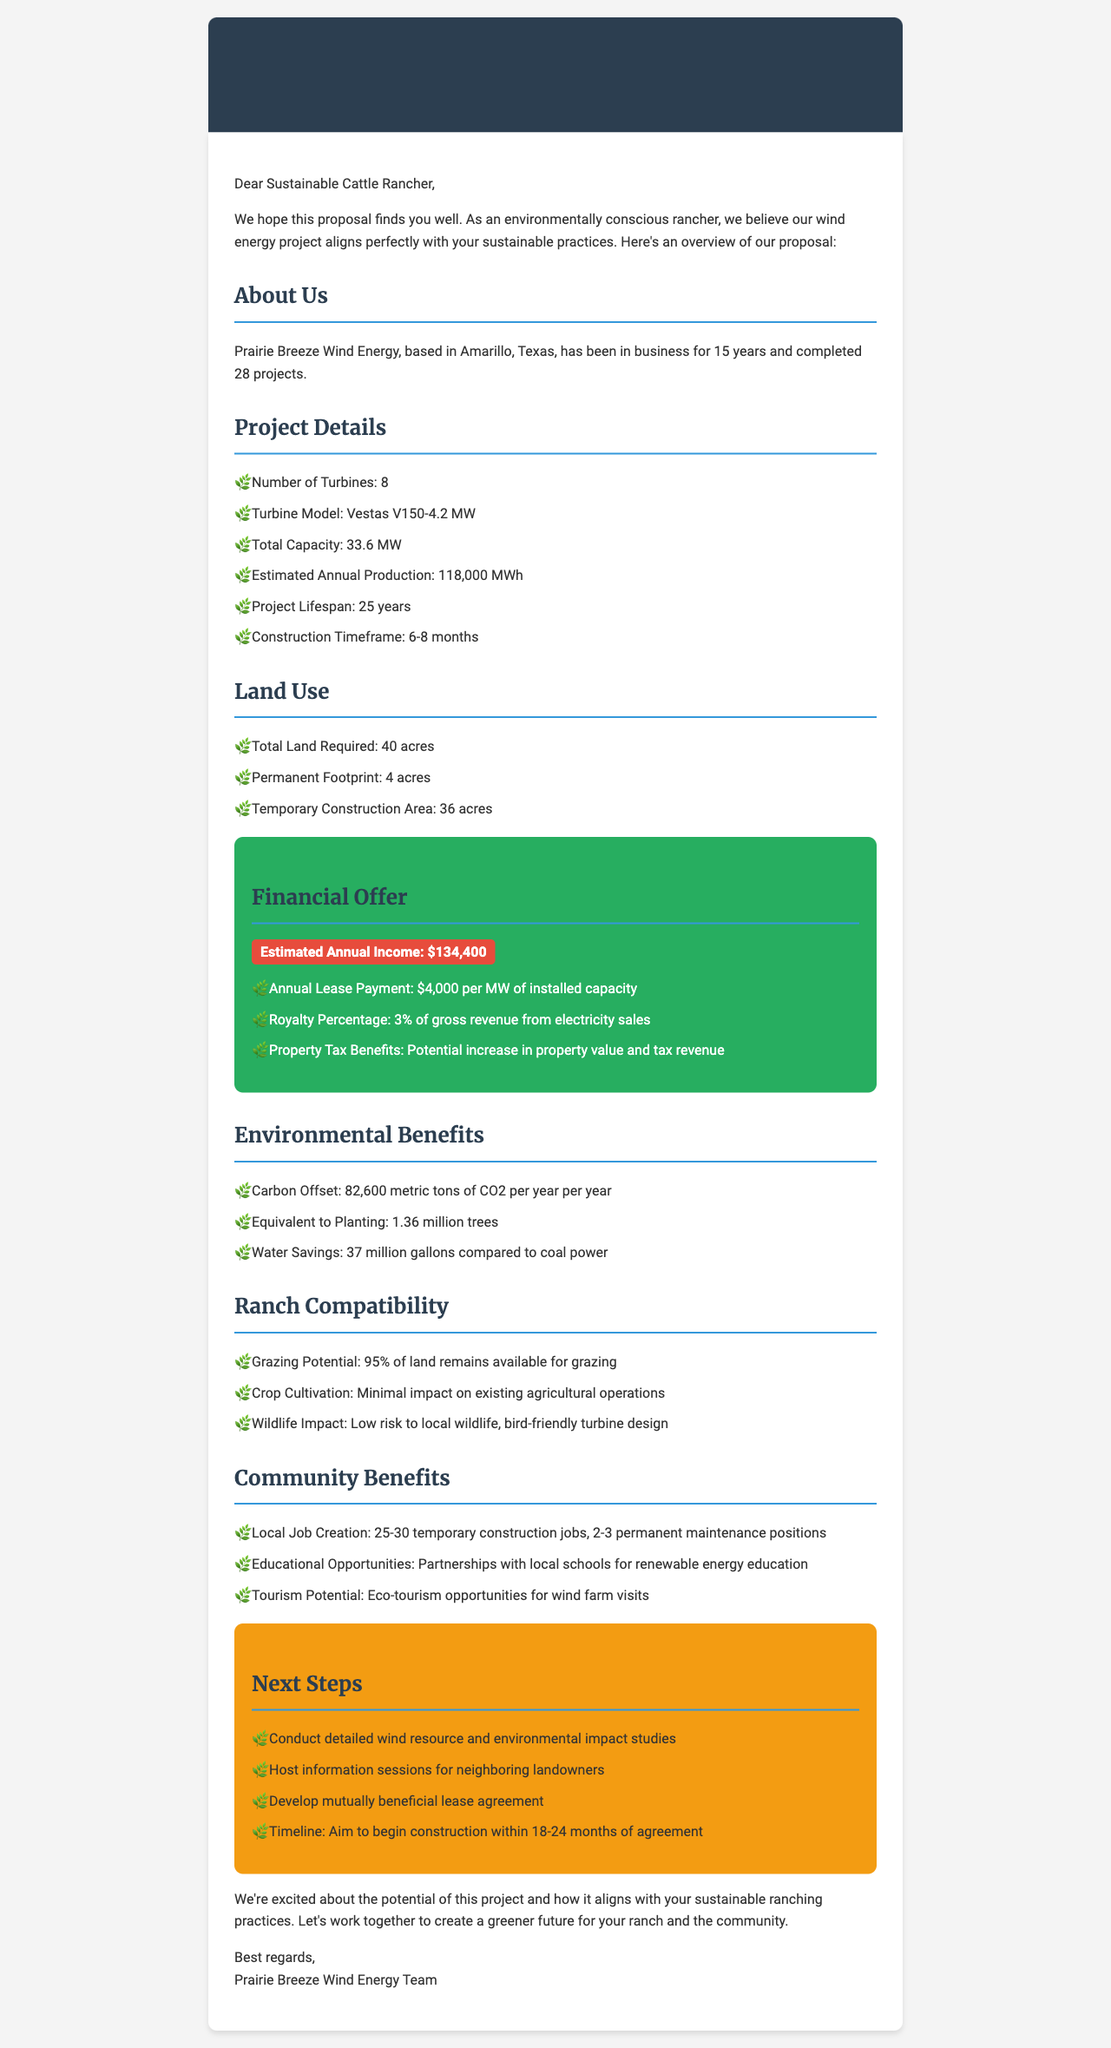What is the name of the wind energy company? The name of the company is found in the introduction section of the document.
Answer: Prairie Breeze Wind Energy How many turbines are proposed for installation? This information is clearly listed under the Project Details section.
Answer: 8 What is the estimated annual production of electricity? The estimated annual production is stated under the Project Details section.
Answer: 118,000 MWh What is the annual lease payment per MW of installed capacity? The annual lease payment is detailed in the Financial Offer section.
Answer: $4,000 per MW How much CO2 is estimated to be offset per year? This information can be found in the Environmental Benefits section of the document.
Answer: 82,600 metric tons What percentage of gross revenue will the royalty be? The royalty percentage is mentioned in the Financial Offer section.
Answer: 3% What is the total land required for the project? The total land required is presented in the Land Use section.
Answer: 40 acres Is there an impact on local wildlife? This aspect is addressed in the Ranch Compatibility section of the document regarding wildlife impact.
Answer: Low risk What is the construction timeframe for the project? The construction timeframe is highlighted under the Project Details section.
Answer: 6-8 months 